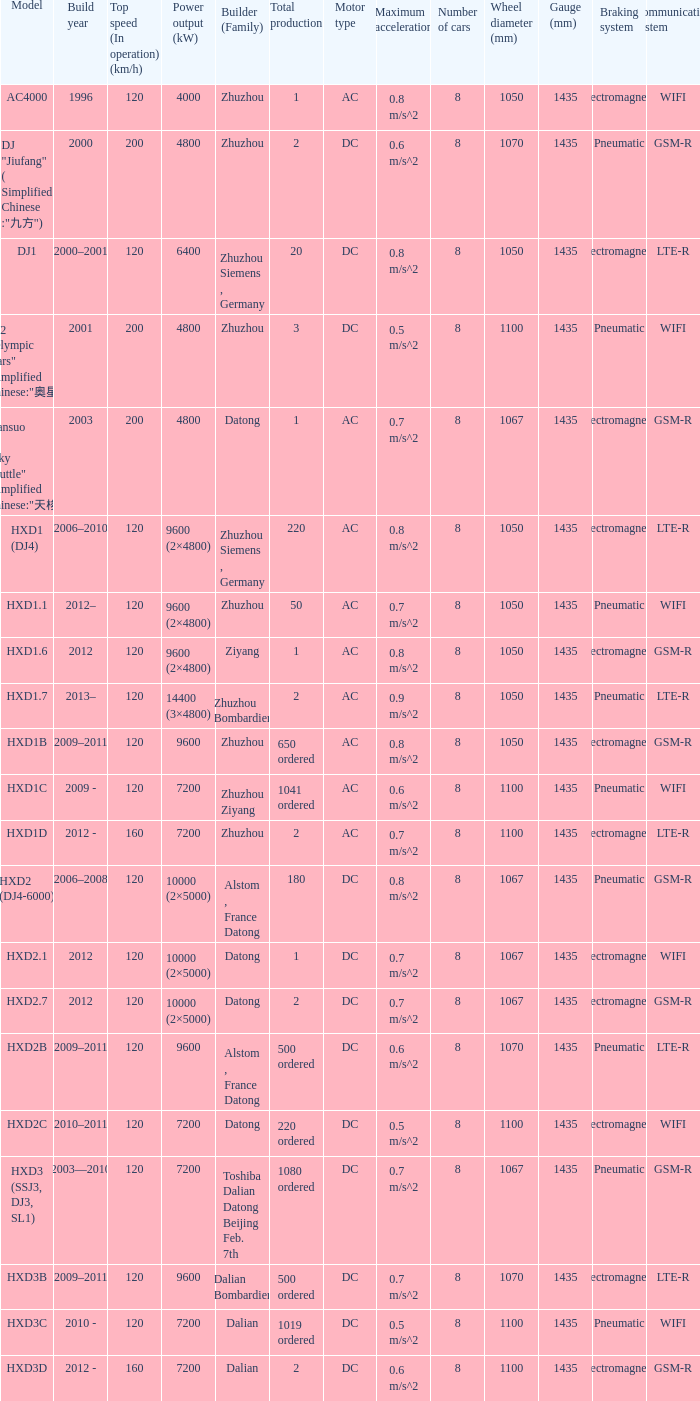What is the power output (kw) of model hxd2b? 9600.0. 